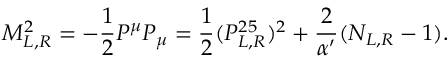Convert formula to latex. <formula><loc_0><loc_0><loc_500><loc_500>M _ { L , R } ^ { 2 } = - \frac { 1 } { 2 } P ^ { \mu } P _ { \mu } = \frac { 1 } { 2 } ( P _ { L , R } ^ { 2 5 } ) ^ { 2 } + \frac { 2 } { \alpha ^ { \prime } } ( N _ { L , R } - 1 ) .</formula> 